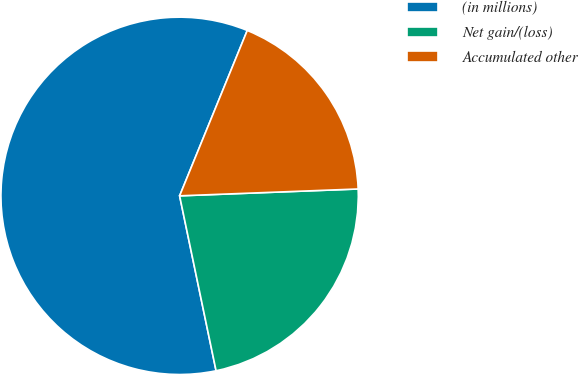<chart> <loc_0><loc_0><loc_500><loc_500><pie_chart><fcel>(in millions)<fcel>Net gain/(loss)<fcel>Accumulated other<nl><fcel>59.45%<fcel>22.34%<fcel>18.21%<nl></chart> 